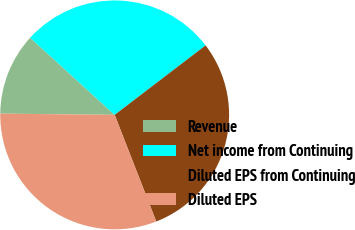<chart> <loc_0><loc_0><loc_500><loc_500><pie_chart><fcel>Revenue<fcel>Net income from Continuing<fcel>Diluted EPS from Continuing<fcel>Diluted EPS<nl><fcel>11.6%<fcel>27.84%<fcel>29.47%<fcel>31.09%<nl></chart> 